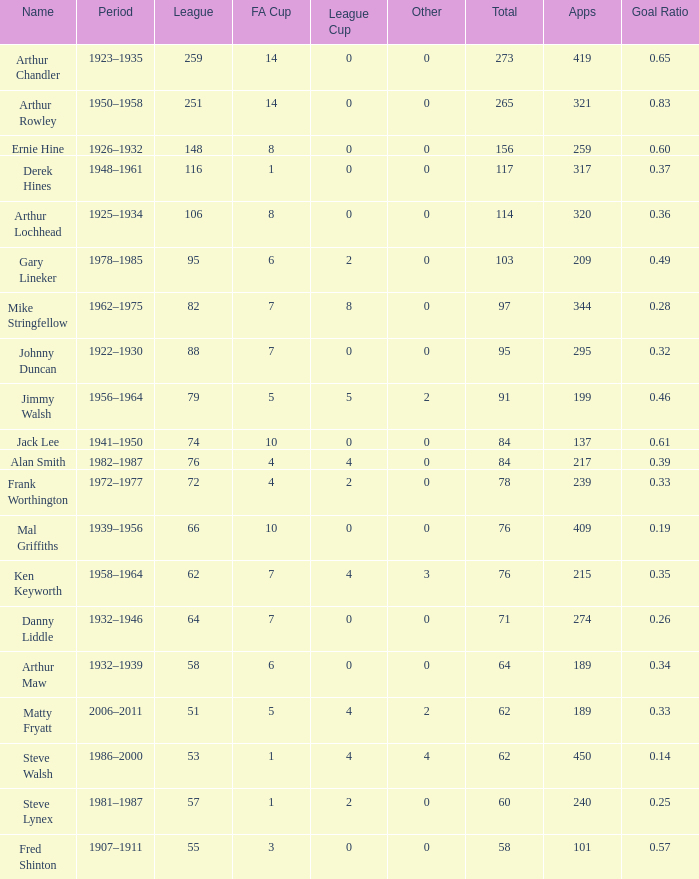What's the highest FA Cup with the Name of Alan Smith, and League Cup smaller than 4? None. 